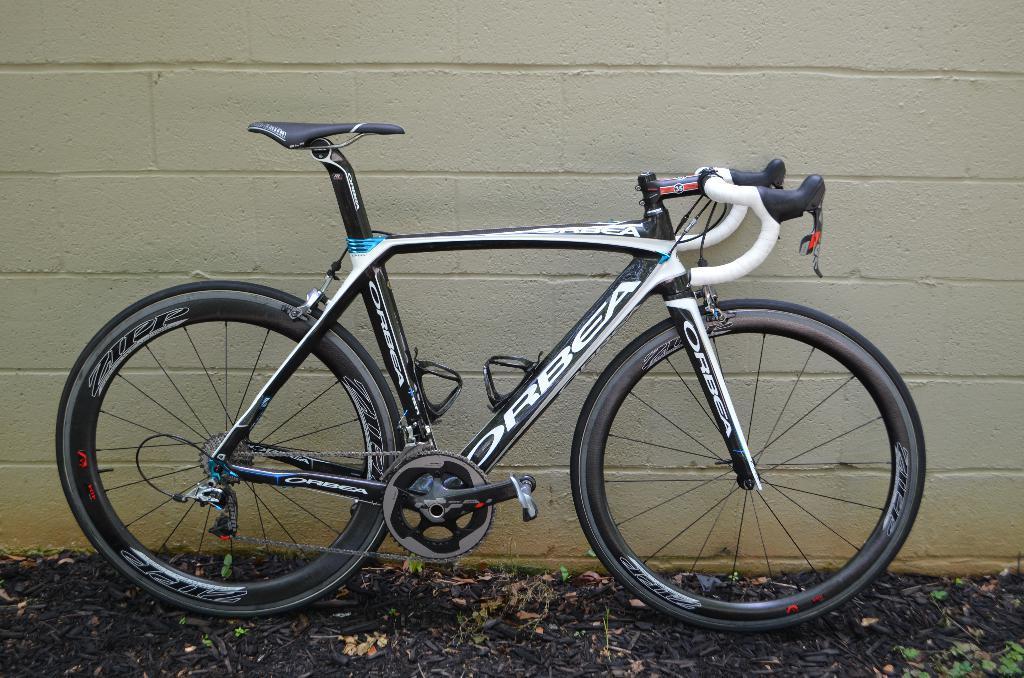Please provide a concise description of this image. In this picture there is a bicycle which is parked near to the wall. At the bottom we can see many leaves. 